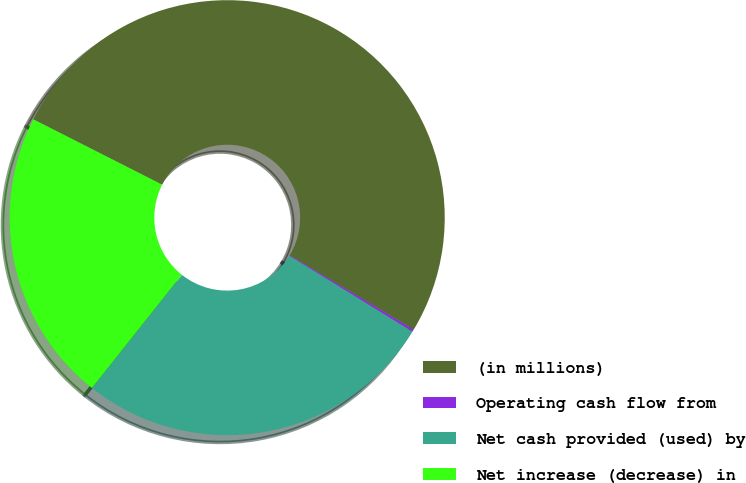Convert chart to OTSL. <chart><loc_0><loc_0><loc_500><loc_500><pie_chart><fcel>(in millions)<fcel>Operating cash flow from<fcel>Net cash provided (used) by<fcel>Net increase (decrease) in<nl><fcel>51.14%<fcel>0.18%<fcel>26.89%<fcel>21.79%<nl></chart> 